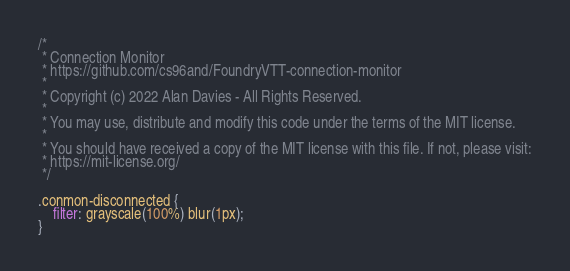<code> <loc_0><loc_0><loc_500><loc_500><_CSS_>/*
 * Connection Monitor
 * https://github.com/cs96and/FoundryVTT-connection-monitor
 *
 * Copyright (c) 2022 Alan Davies - All Rights Reserved.
 *
 * You may use, distribute and modify this code under the terms of the MIT license.
 *
 * You should have received a copy of the MIT license with this file. If not, please visit:
 * https://mit-license.org/
 */

.conmon-disconnected {
	filter: grayscale(100%) blur(1px);
}
</code> 